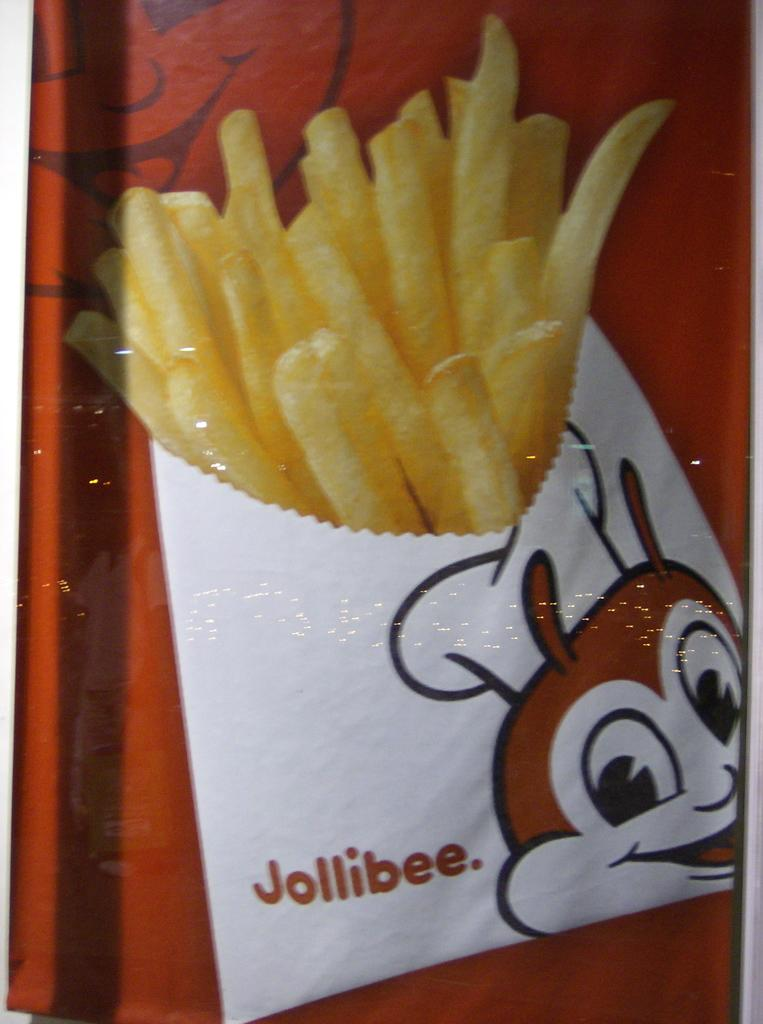What type of food is depicted in the image? There is a picture of french fries in the image. What style of image is present in the image? There is a cartoon image in the image. What color is the background of the image? The background of the image is red. Where is the goat located in the image? There is no goat present in the image. What type of scarecrow can be seen in the image? There is no scarecrowcrow present in the image. 